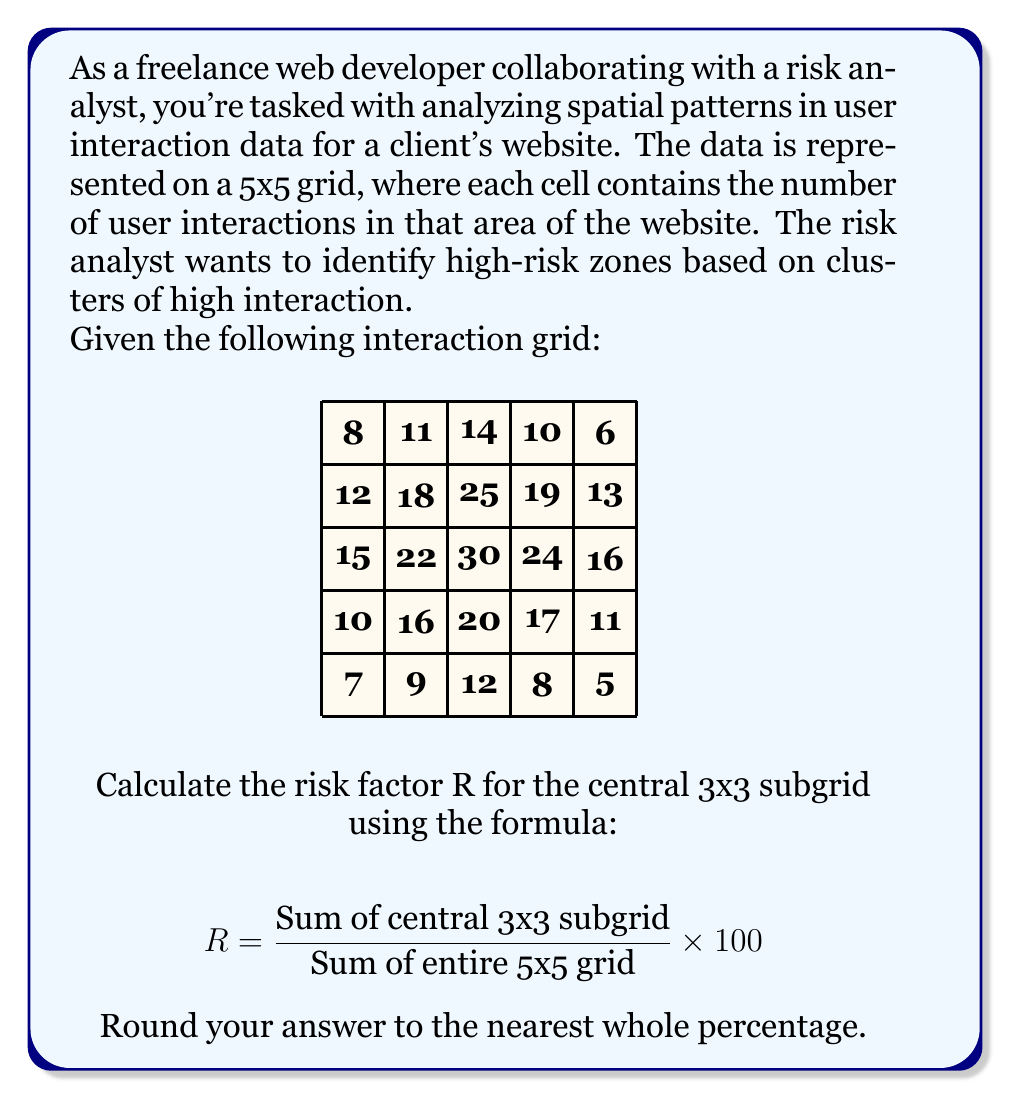Can you solve this math problem? To solve this problem, we'll follow these steps:

1. Sum the values in the central 3x3 subgrid:
   $18 + 22 + 16 + 25 + 30 + 20 + 19 + 24 + 17 = 191$

2. Sum all values in the 5x5 grid:
   $8 + 12 + 15 + 10 + 7 + 11 + 18 + 22 + 16 + 9 + 14 + 25 + 30 + 20 + 12 + 10 + 19 + 24 + 17 + 8 + 6 + 13 + 16 + 11 + 5 = 378$

3. Apply the formula:
   $$ R = \frac{191}{378} \times 100 \approx 50.5291 $$

4. Round to the nearest whole percentage:
   50.5291 rounds to 51%

Therefore, the risk factor R for the central 3x3 subgrid is 51%.
Answer: 51% 